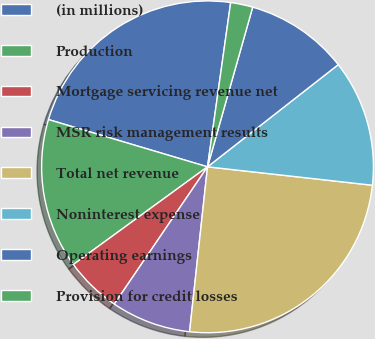Convert chart to OTSL. <chart><loc_0><loc_0><loc_500><loc_500><pie_chart><fcel>(in millions)<fcel>Production<fcel>Mortgage servicing revenue net<fcel>MSR risk management results<fcel>Total net revenue<fcel>Noninterest expense<fcel>Operating earnings<fcel>Provision for credit losses<nl><fcel>22.63%<fcel>14.61%<fcel>5.49%<fcel>7.77%<fcel>24.95%<fcel>12.33%<fcel>10.05%<fcel>2.16%<nl></chart> 